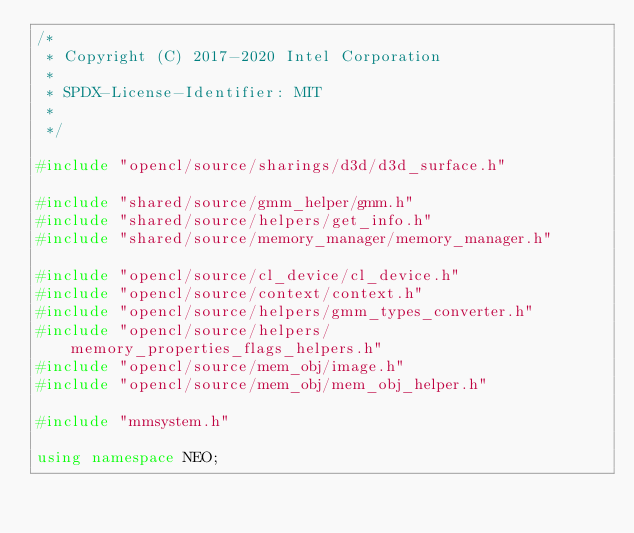Convert code to text. <code><loc_0><loc_0><loc_500><loc_500><_C++_>/*
 * Copyright (C) 2017-2020 Intel Corporation
 *
 * SPDX-License-Identifier: MIT
 *
 */

#include "opencl/source/sharings/d3d/d3d_surface.h"

#include "shared/source/gmm_helper/gmm.h"
#include "shared/source/helpers/get_info.h"
#include "shared/source/memory_manager/memory_manager.h"

#include "opencl/source/cl_device/cl_device.h"
#include "opencl/source/context/context.h"
#include "opencl/source/helpers/gmm_types_converter.h"
#include "opencl/source/helpers/memory_properties_flags_helpers.h"
#include "opencl/source/mem_obj/image.h"
#include "opencl/source/mem_obj/mem_obj_helper.h"

#include "mmsystem.h"

using namespace NEO;
</code> 